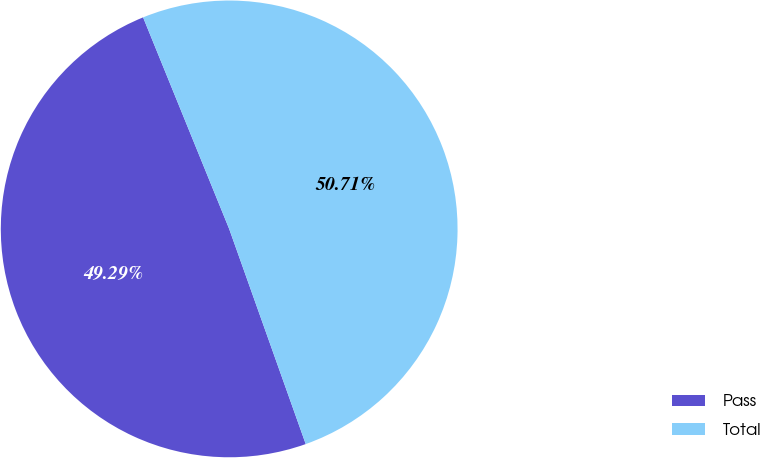Convert chart to OTSL. <chart><loc_0><loc_0><loc_500><loc_500><pie_chart><fcel>Pass<fcel>Total<nl><fcel>49.29%<fcel>50.71%<nl></chart> 